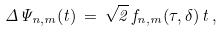Convert formula to latex. <formula><loc_0><loc_0><loc_500><loc_500>\Delta \Psi _ { n , m } ( t ) \, = \, \sqrt { 2 } \, f _ { n , m } ( \tau , \delta ) \, t \, ,</formula> 